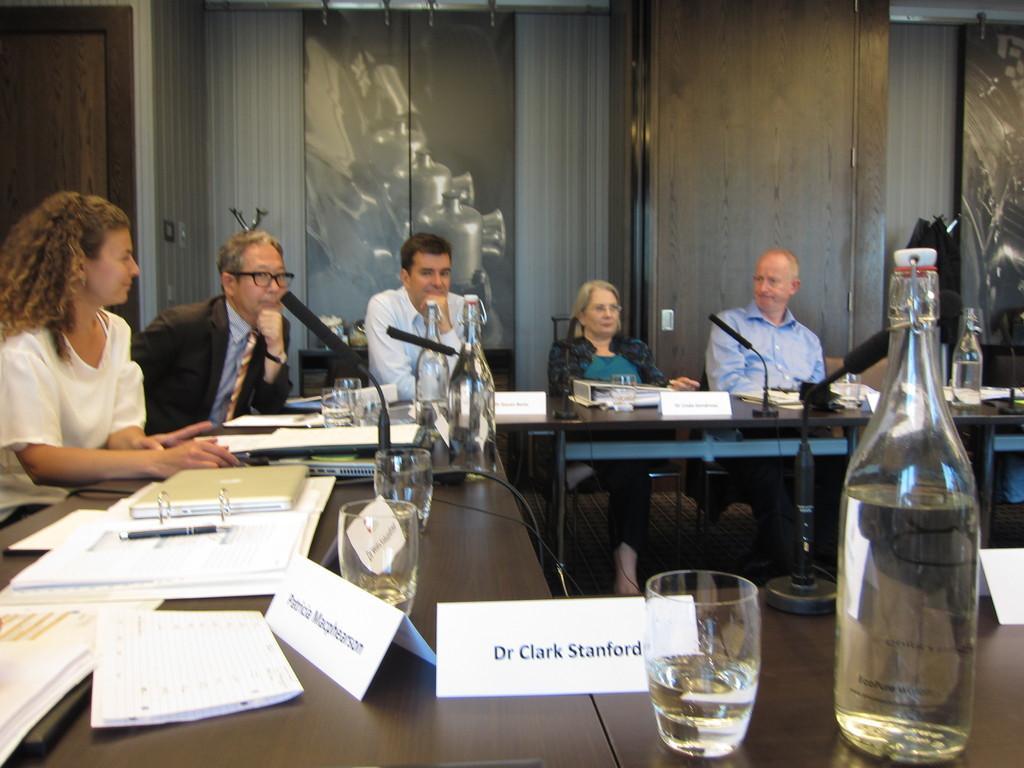In one or two sentences, can you explain what this image depicts? In this image I can see a five person sitting on the chair. On the table there is a laptop,book,pen and glass. There is a bottle and a mic. 